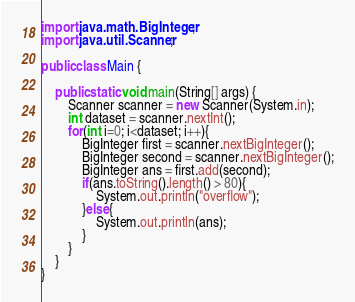Convert code to text. <code><loc_0><loc_0><loc_500><loc_500><_Java_>import java.math.BigInteger;
import java.util.Scanner;

public class Main {

	public static void main(String[] args) {
		Scanner scanner = new Scanner(System.in);
		int dataset = scanner.nextInt();
		for(int i=0; i<dataset; i++){
			BigInteger first = scanner.nextBigInteger();
			BigInteger second = scanner.nextBigInteger();
			BigInteger ans = first.add(second);
			if(ans.toString().length() > 80){
				System.out.println("overflow");
			}else{
				System.out.println(ans);
			}
		}
	}
}</code> 